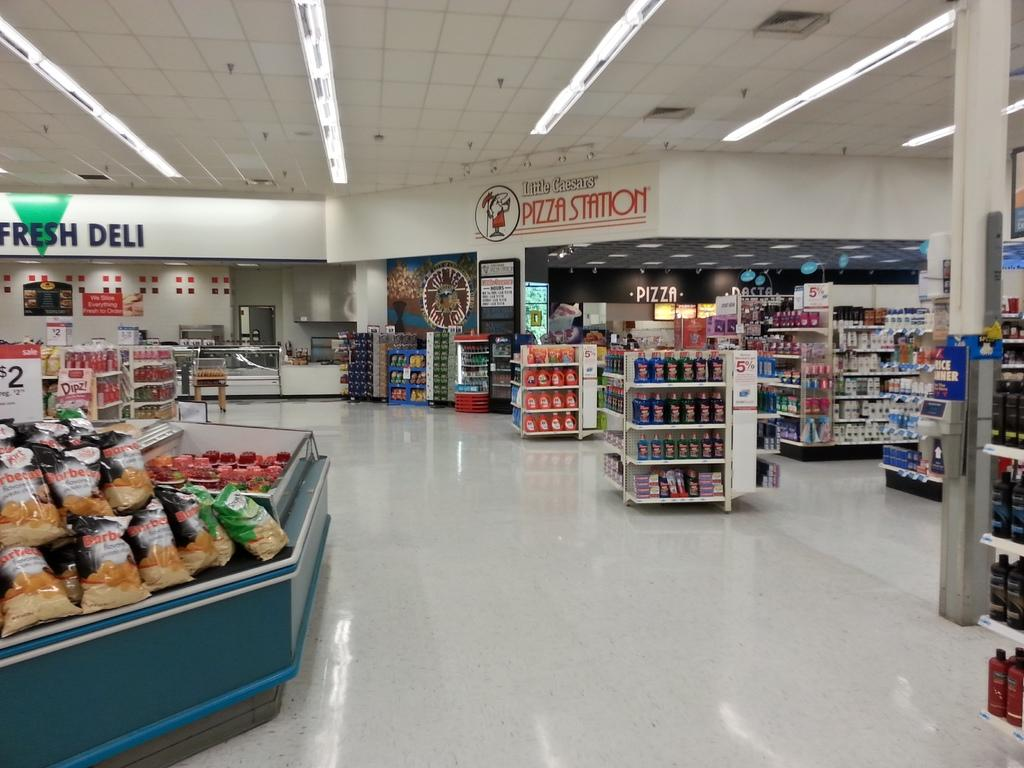<image>
Give a short and clear explanation of the subsequent image. Grocery store that have products and deli included. 